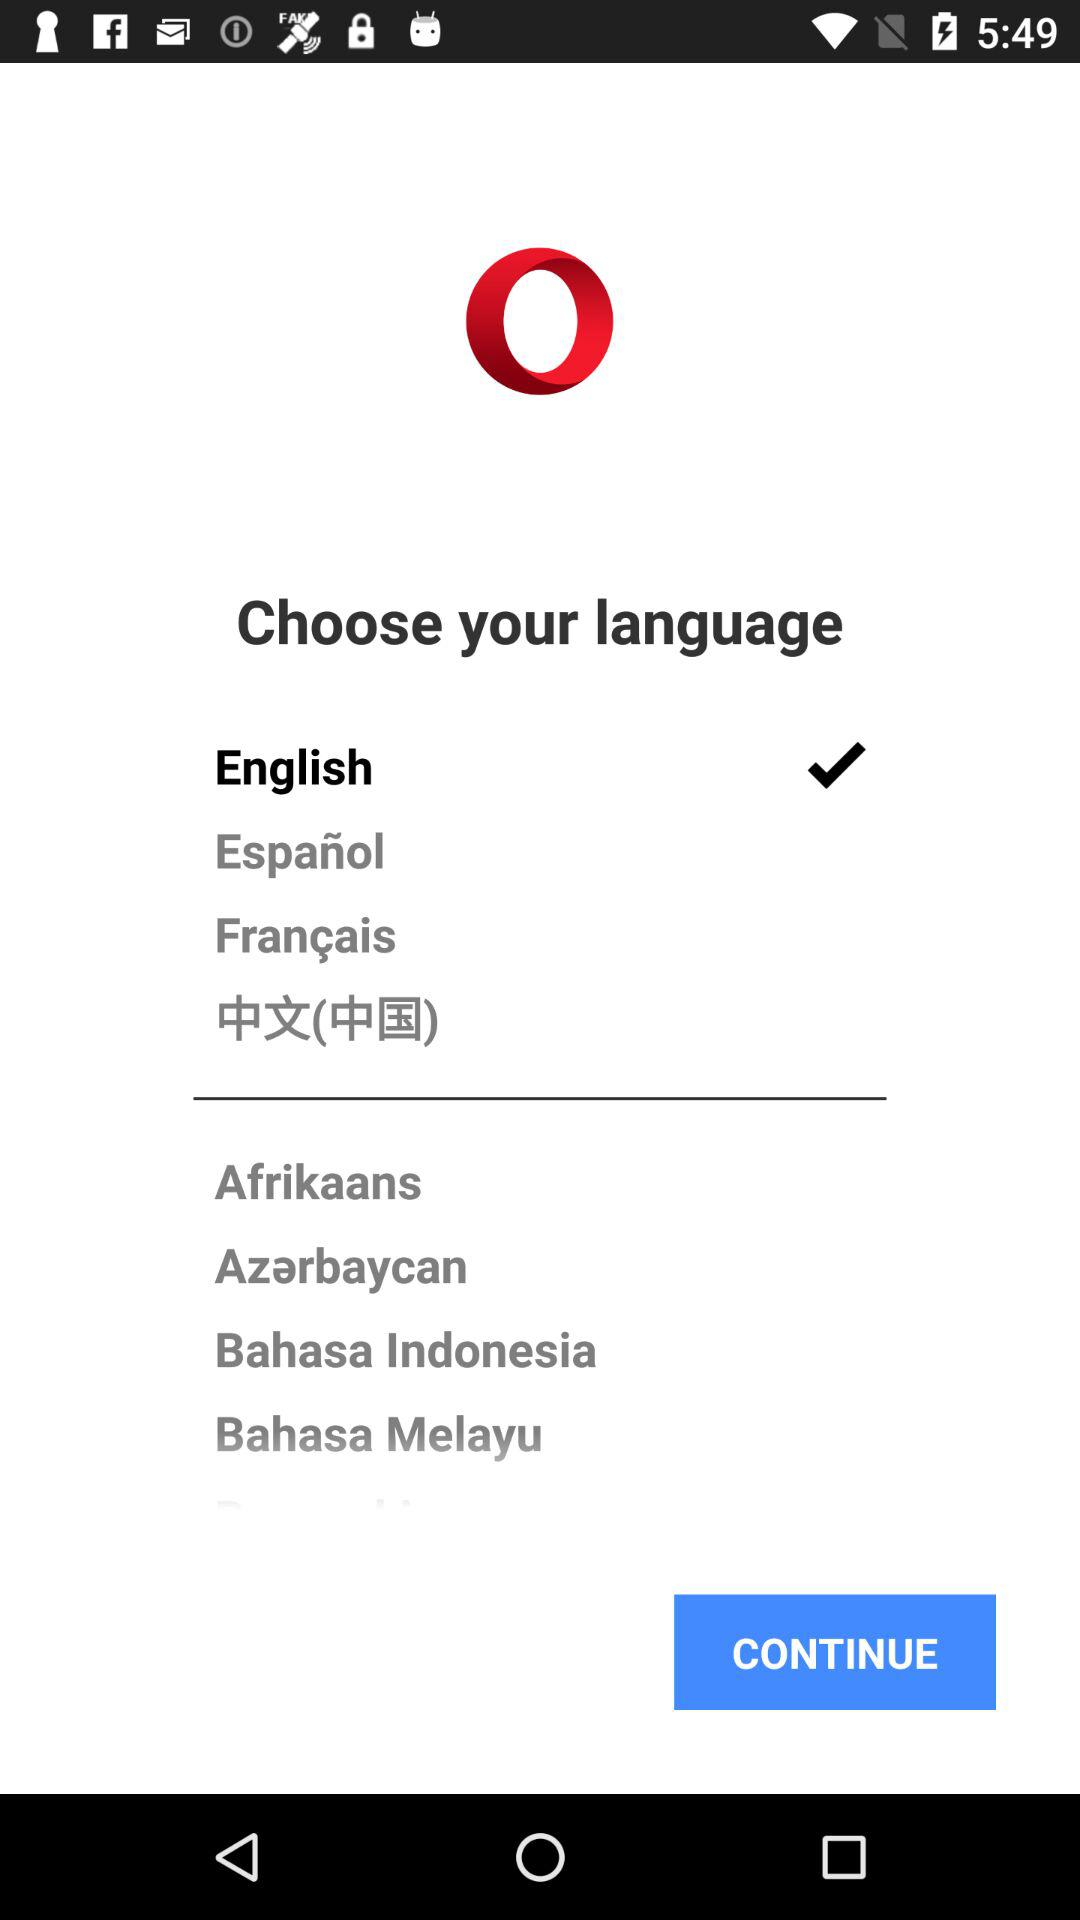Which is the selected language? The selected language is "English". 